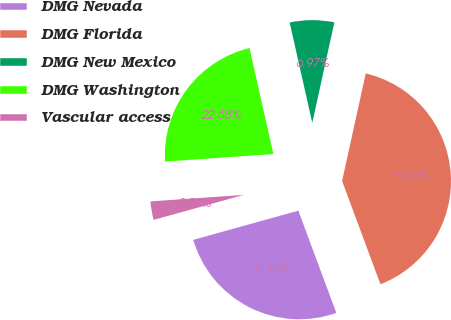<chart> <loc_0><loc_0><loc_500><loc_500><pie_chart><fcel>DMG Nevada<fcel>DMG Florida<fcel>DMG New Mexico<fcel>DMG Washington<fcel>Vascular access<nl><fcel>26.35%<fcel>40.89%<fcel>6.97%<fcel>22.58%<fcel>3.2%<nl></chart> 